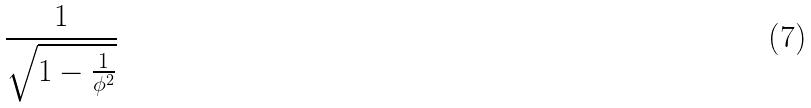<formula> <loc_0><loc_0><loc_500><loc_500>\frac { 1 } { \sqrt { 1 - \frac { 1 } { \phi ^ { 2 } } } }</formula> 